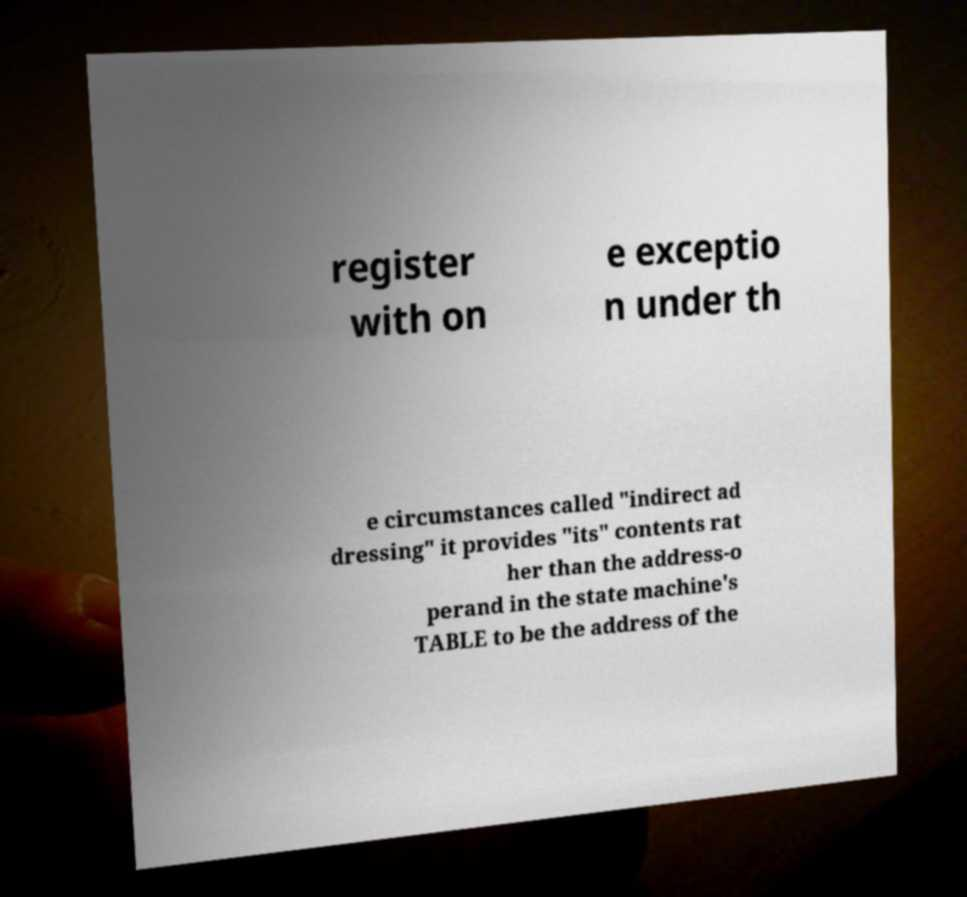Please read and relay the text visible in this image. What does it say? register with on e exceptio n under th e circumstances called "indirect ad dressing" it provides "its" contents rat her than the address-o perand in the state machine's TABLE to be the address of the 